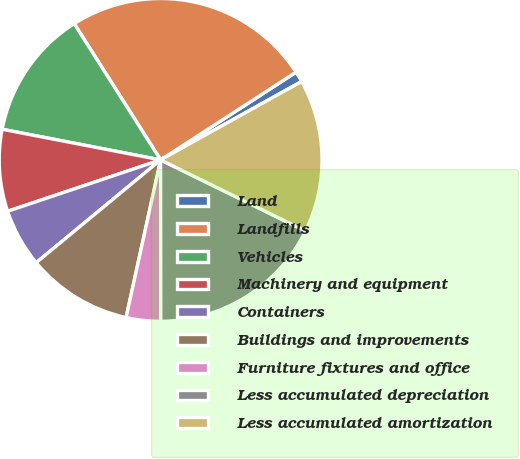Convert chart. <chart><loc_0><loc_0><loc_500><loc_500><pie_chart><fcel>Land<fcel>Landfills<fcel>Vehicles<fcel>Machinery and equipment<fcel>Containers<fcel>Buildings and improvements<fcel>Furniture fixtures and office<fcel>Less accumulated depreciation<fcel>Less accumulated amortization<nl><fcel>1.07%<fcel>24.85%<fcel>12.96%<fcel>8.2%<fcel>5.83%<fcel>10.58%<fcel>3.45%<fcel>17.72%<fcel>15.34%<nl></chart> 